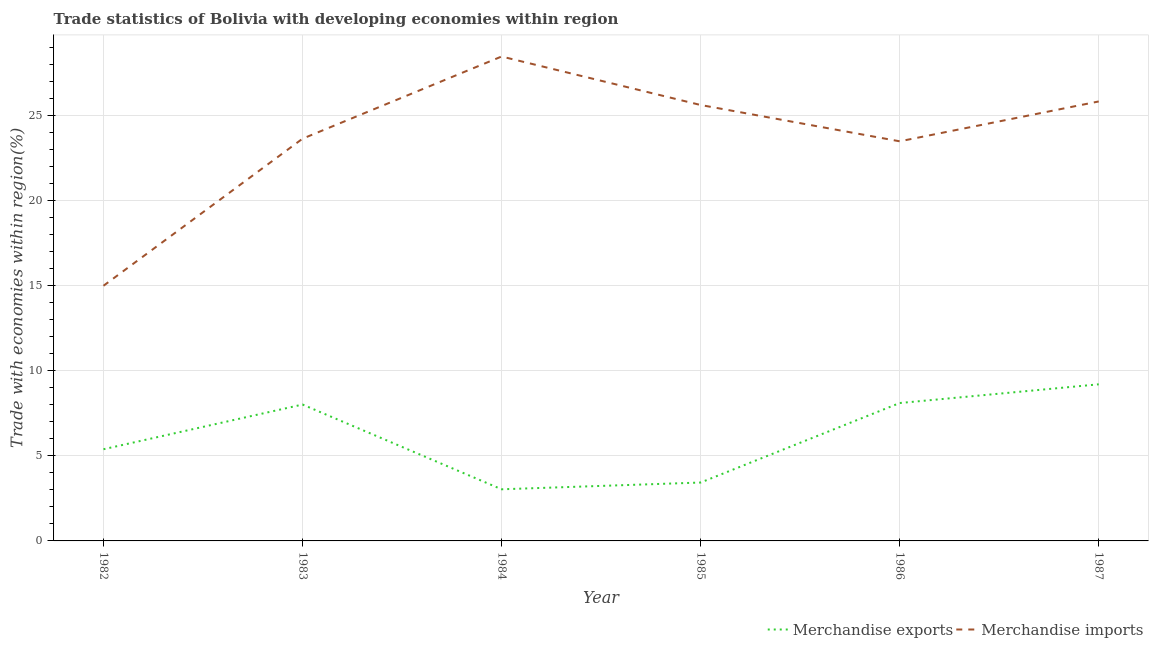How many different coloured lines are there?
Your response must be concise. 2. Does the line corresponding to merchandise imports intersect with the line corresponding to merchandise exports?
Offer a terse response. No. Is the number of lines equal to the number of legend labels?
Give a very brief answer. Yes. What is the merchandise exports in 1986?
Your answer should be compact. 8.1. Across all years, what is the maximum merchandise imports?
Offer a terse response. 28.47. Across all years, what is the minimum merchandise imports?
Your answer should be very brief. 15. In which year was the merchandise exports maximum?
Your answer should be very brief. 1987. In which year was the merchandise imports minimum?
Your answer should be very brief. 1982. What is the total merchandise imports in the graph?
Offer a very short reply. 142.05. What is the difference between the merchandise imports in 1983 and that in 1987?
Offer a very short reply. -2.19. What is the difference between the merchandise imports in 1985 and the merchandise exports in 1983?
Your response must be concise. 17.6. What is the average merchandise exports per year?
Your answer should be very brief. 6.2. In the year 1984, what is the difference between the merchandise imports and merchandise exports?
Your answer should be very brief. 25.44. In how many years, is the merchandise imports greater than 27 %?
Your answer should be very brief. 1. What is the ratio of the merchandise imports in 1982 to that in 1986?
Keep it short and to the point. 0.64. What is the difference between the highest and the second highest merchandise exports?
Your response must be concise. 1.1. What is the difference between the highest and the lowest merchandise exports?
Provide a short and direct response. 6.17. In how many years, is the merchandise imports greater than the average merchandise imports taken over all years?
Your answer should be very brief. 3. Is the sum of the merchandise exports in 1985 and 1987 greater than the maximum merchandise imports across all years?
Your response must be concise. No. Does the merchandise imports monotonically increase over the years?
Offer a very short reply. No. What is the difference between two consecutive major ticks on the Y-axis?
Your answer should be compact. 5. Does the graph contain any zero values?
Ensure brevity in your answer.  No. Where does the legend appear in the graph?
Ensure brevity in your answer.  Bottom right. How many legend labels are there?
Give a very brief answer. 2. How are the legend labels stacked?
Make the answer very short. Horizontal. What is the title of the graph?
Your answer should be compact. Trade statistics of Bolivia with developing economies within region. What is the label or title of the X-axis?
Keep it short and to the point. Year. What is the label or title of the Y-axis?
Give a very brief answer. Trade with economies within region(%). What is the Trade with economies within region(%) in Merchandise exports in 1982?
Make the answer very short. 5.39. What is the Trade with economies within region(%) in Merchandise imports in 1982?
Provide a succinct answer. 15. What is the Trade with economies within region(%) of Merchandise exports in 1983?
Your answer should be very brief. 8.02. What is the Trade with economies within region(%) in Merchandise imports in 1983?
Keep it short and to the point. 23.64. What is the Trade with economies within region(%) of Merchandise exports in 1984?
Provide a succinct answer. 3.04. What is the Trade with economies within region(%) of Merchandise imports in 1984?
Offer a terse response. 28.47. What is the Trade with economies within region(%) in Merchandise exports in 1985?
Make the answer very short. 3.43. What is the Trade with economies within region(%) in Merchandise imports in 1985?
Give a very brief answer. 25.62. What is the Trade with economies within region(%) of Merchandise exports in 1986?
Offer a very short reply. 8.1. What is the Trade with economies within region(%) of Merchandise imports in 1986?
Your response must be concise. 23.49. What is the Trade with economies within region(%) in Merchandise exports in 1987?
Your answer should be very brief. 9.2. What is the Trade with economies within region(%) of Merchandise imports in 1987?
Give a very brief answer. 25.83. Across all years, what is the maximum Trade with economies within region(%) in Merchandise exports?
Offer a very short reply. 9.2. Across all years, what is the maximum Trade with economies within region(%) in Merchandise imports?
Provide a succinct answer. 28.47. Across all years, what is the minimum Trade with economies within region(%) of Merchandise exports?
Offer a very short reply. 3.04. Across all years, what is the minimum Trade with economies within region(%) of Merchandise imports?
Provide a short and direct response. 15. What is the total Trade with economies within region(%) in Merchandise exports in the graph?
Your answer should be compact. 37.18. What is the total Trade with economies within region(%) of Merchandise imports in the graph?
Keep it short and to the point. 142.05. What is the difference between the Trade with economies within region(%) of Merchandise exports in 1982 and that in 1983?
Your response must be concise. -2.63. What is the difference between the Trade with economies within region(%) in Merchandise imports in 1982 and that in 1983?
Provide a succinct answer. -8.64. What is the difference between the Trade with economies within region(%) in Merchandise exports in 1982 and that in 1984?
Keep it short and to the point. 2.35. What is the difference between the Trade with economies within region(%) of Merchandise imports in 1982 and that in 1984?
Your answer should be compact. -13.47. What is the difference between the Trade with economies within region(%) of Merchandise exports in 1982 and that in 1985?
Offer a very short reply. 1.96. What is the difference between the Trade with economies within region(%) of Merchandise imports in 1982 and that in 1985?
Your answer should be very brief. -10.62. What is the difference between the Trade with economies within region(%) in Merchandise exports in 1982 and that in 1986?
Offer a very short reply. -2.72. What is the difference between the Trade with economies within region(%) in Merchandise imports in 1982 and that in 1986?
Give a very brief answer. -8.49. What is the difference between the Trade with economies within region(%) in Merchandise exports in 1982 and that in 1987?
Give a very brief answer. -3.82. What is the difference between the Trade with economies within region(%) in Merchandise imports in 1982 and that in 1987?
Ensure brevity in your answer.  -10.83. What is the difference between the Trade with economies within region(%) in Merchandise exports in 1983 and that in 1984?
Provide a succinct answer. 4.98. What is the difference between the Trade with economies within region(%) of Merchandise imports in 1983 and that in 1984?
Your response must be concise. -4.83. What is the difference between the Trade with economies within region(%) in Merchandise exports in 1983 and that in 1985?
Offer a very short reply. 4.58. What is the difference between the Trade with economies within region(%) of Merchandise imports in 1983 and that in 1985?
Make the answer very short. -1.98. What is the difference between the Trade with economies within region(%) in Merchandise exports in 1983 and that in 1986?
Offer a terse response. -0.09. What is the difference between the Trade with economies within region(%) of Merchandise imports in 1983 and that in 1986?
Your answer should be compact. 0.15. What is the difference between the Trade with economies within region(%) in Merchandise exports in 1983 and that in 1987?
Provide a short and direct response. -1.19. What is the difference between the Trade with economies within region(%) in Merchandise imports in 1983 and that in 1987?
Your response must be concise. -2.19. What is the difference between the Trade with economies within region(%) in Merchandise exports in 1984 and that in 1985?
Provide a succinct answer. -0.4. What is the difference between the Trade with economies within region(%) in Merchandise imports in 1984 and that in 1985?
Ensure brevity in your answer.  2.85. What is the difference between the Trade with economies within region(%) in Merchandise exports in 1984 and that in 1986?
Provide a succinct answer. -5.07. What is the difference between the Trade with economies within region(%) in Merchandise imports in 1984 and that in 1986?
Your answer should be very brief. 4.98. What is the difference between the Trade with economies within region(%) of Merchandise exports in 1984 and that in 1987?
Your answer should be compact. -6.17. What is the difference between the Trade with economies within region(%) in Merchandise imports in 1984 and that in 1987?
Offer a terse response. 2.64. What is the difference between the Trade with economies within region(%) of Merchandise exports in 1985 and that in 1986?
Your response must be concise. -4.67. What is the difference between the Trade with economies within region(%) of Merchandise imports in 1985 and that in 1986?
Keep it short and to the point. 2.13. What is the difference between the Trade with economies within region(%) in Merchandise exports in 1985 and that in 1987?
Provide a succinct answer. -5.77. What is the difference between the Trade with economies within region(%) of Merchandise imports in 1985 and that in 1987?
Provide a succinct answer. -0.21. What is the difference between the Trade with economies within region(%) of Merchandise exports in 1986 and that in 1987?
Offer a terse response. -1.1. What is the difference between the Trade with economies within region(%) of Merchandise imports in 1986 and that in 1987?
Provide a short and direct response. -2.34. What is the difference between the Trade with economies within region(%) in Merchandise exports in 1982 and the Trade with economies within region(%) in Merchandise imports in 1983?
Offer a terse response. -18.25. What is the difference between the Trade with economies within region(%) in Merchandise exports in 1982 and the Trade with economies within region(%) in Merchandise imports in 1984?
Ensure brevity in your answer.  -23.08. What is the difference between the Trade with economies within region(%) in Merchandise exports in 1982 and the Trade with economies within region(%) in Merchandise imports in 1985?
Give a very brief answer. -20.23. What is the difference between the Trade with economies within region(%) of Merchandise exports in 1982 and the Trade with economies within region(%) of Merchandise imports in 1986?
Keep it short and to the point. -18.1. What is the difference between the Trade with economies within region(%) in Merchandise exports in 1982 and the Trade with economies within region(%) in Merchandise imports in 1987?
Provide a succinct answer. -20.44. What is the difference between the Trade with economies within region(%) of Merchandise exports in 1983 and the Trade with economies within region(%) of Merchandise imports in 1984?
Make the answer very short. -20.46. What is the difference between the Trade with economies within region(%) of Merchandise exports in 1983 and the Trade with economies within region(%) of Merchandise imports in 1985?
Offer a terse response. -17.6. What is the difference between the Trade with economies within region(%) of Merchandise exports in 1983 and the Trade with economies within region(%) of Merchandise imports in 1986?
Your answer should be compact. -15.47. What is the difference between the Trade with economies within region(%) in Merchandise exports in 1983 and the Trade with economies within region(%) in Merchandise imports in 1987?
Provide a succinct answer. -17.81. What is the difference between the Trade with economies within region(%) in Merchandise exports in 1984 and the Trade with economies within region(%) in Merchandise imports in 1985?
Your answer should be compact. -22.59. What is the difference between the Trade with economies within region(%) of Merchandise exports in 1984 and the Trade with economies within region(%) of Merchandise imports in 1986?
Your response must be concise. -20.45. What is the difference between the Trade with economies within region(%) of Merchandise exports in 1984 and the Trade with economies within region(%) of Merchandise imports in 1987?
Keep it short and to the point. -22.8. What is the difference between the Trade with economies within region(%) of Merchandise exports in 1985 and the Trade with economies within region(%) of Merchandise imports in 1986?
Ensure brevity in your answer.  -20.06. What is the difference between the Trade with economies within region(%) in Merchandise exports in 1985 and the Trade with economies within region(%) in Merchandise imports in 1987?
Your response must be concise. -22.4. What is the difference between the Trade with economies within region(%) of Merchandise exports in 1986 and the Trade with economies within region(%) of Merchandise imports in 1987?
Your answer should be very brief. -17.73. What is the average Trade with economies within region(%) of Merchandise exports per year?
Provide a short and direct response. 6.2. What is the average Trade with economies within region(%) in Merchandise imports per year?
Your response must be concise. 23.67. In the year 1982, what is the difference between the Trade with economies within region(%) in Merchandise exports and Trade with economies within region(%) in Merchandise imports?
Offer a very short reply. -9.61. In the year 1983, what is the difference between the Trade with economies within region(%) in Merchandise exports and Trade with economies within region(%) in Merchandise imports?
Provide a succinct answer. -15.62. In the year 1984, what is the difference between the Trade with economies within region(%) of Merchandise exports and Trade with economies within region(%) of Merchandise imports?
Ensure brevity in your answer.  -25.44. In the year 1985, what is the difference between the Trade with economies within region(%) of Merchandise exports and Trade with economies within region(%) of Merchandise imports?
Provide a short and direct response. -22.19. In the year 1986, what is the difference between the Trade with economies within region(%) in Merchandise exports and Trade with economies within region(%) in Merchandise imports?
Your answer should be very brief. -15.38. In the year 1987, what is the difference between the Trade with economies within region(%) in Merchandise exports and Trade with economies within region(%) in Merchandise imports?
Ensure brevity in your answer.  -16.63. What is the ratio of the Trade with economies within region(%) in Merchandise exports in 1982 to that in 1983?
Provide a succinct answer. 0.67. What is the ratio of the Trade with economies within region(%) of Merchandise imports in 1982 to that in 1983?
Make the answer very short. 0.63. What is the ratio of the Trade with economies within region(%) of Merchandise exports in 1982 to that in 1984?
Keep it short and to the point. 1.78. What is the ratio of the Trade with economies within region(%) in Merchandise imports in 1982 to that in 1984?
Keep it short and to the point. 0.53. What is the ratio of the Trade with economies within region(%) in Merchandise exports in 1982 to that in 1985?
Your response must be concise. 1.57. What is the ratio of the Trade with economies within region(%) of Merchandise imports in 1982 to that in 1985?
Make the answer very short. 0.59. What is the ratio of the Trade with economies within region(%) in Merchandise exports in 1982 to that in 1986?
Provide a short and direct response. 0.66. What is the ratio of the Trade with economies within region(%) in Merchandise imports in 1982 to that in 1986?
Provide a short and direct response. 0.64. What is the ratio of the Trade with economies within region(%) of Merchandise exports in 1982 to that in 1987?
Give a very brief answer. 0.59. What is the ratio of the Trade with economies within region(%) in Merchandise imports in 1982 to that in 1987?
Offer a very short reply. 0.58. What is the ratio of the Trade with economies within region(%) in Merchandise exports in 1983 to that in 1984?
Ensure brevity in your answer.  2.64. What is the ratio of the Trade with economies within region(%) in Merchandise imports in 1983 to that in 1984?
Your answer should be very brief. 0.83. What is the ratio of the Trade with economies within region(%) of Merchandise exports in 1983 to that in 1985?
Your answer should be compact. 2.34. What is the ratio of the Trade with economies within region(%) in Merchandise imports in 1983 to that in 1985?
Ensure brevity in your answer.  0.92. What is the ratio of the Trade with economies within region(%) in Merchandise exports in 1983 to that in 1986?
Make the answer very short. 0.99. What is the ratio of the Trade with economies within region(%) of Merchandise exports in 1983 to that in 1987?
Offer a terse response. 0.87. What is the ratio of the Trade with economies within region(%) of Merchandise imports in 1983 to that in 1987?
Provide a succinct answer. 0.92. What is the ratio of the Trade with economies within region(%) in Merchandise exports in 1984 to that in 1985?
Your answer should be compact. 0.88. What is the ratio of the Trade with economies within region(%) in Merchandise imports in 1984 to that in 1985?
Provide a succinct answer. 1.11. What is the ratio of the Trade with economies within region(%) in Merchandise exports in 1984 to that in 1986?
Your answer should be compact. 0.37. What is the ratio of the Trade with economies within region(%) in Merchandise imports in 1984 to that in 1986?
Give a very brief answer. 1.21. What is the ratio of the Trade with economies within region(%) in Merchandise exports in 1984 to that in 1987?
Ensure brevity in your answer.  0.33. What is the ratio of the Trade with economies within region(%) in Merchandise imports in 1984 to that in 1987?
Offer a terse response. 1.1. What is the ratio of the Trade with economies within region(%) in Merchandise exports in 1985 to that in 1986?
Offer a very short reply. 0.42. What is the ratio of the Trade with economies within region(%) in Merchandise imports in 1985 to that in 1986?
Keep it short and to the point. 1.09. What is the ratio of the Trade with economies within region(%) in Merchandise exports in 1985 to that in 1987?
Your answer should be compact. 0.37. What is the ratio of the Trade with economies within region(%) of Merchandise exports in 1986 to that in 1987?
Give a very brief answer. 0.88. What is the ratio of the Trade with economies within region(%) in Merchandise imports in 1986 to that in 1987?
Your answer should be very brief. 0.91. What is the difference between the highest and the second highest Trade with economies within region(%) of Merchandise exports?
Your answer should be very brief. 1.1. What is the difference between the highest and the second highest Trade with economies within region(%) in Merchandise imports?
Keep it short and to the point. 2.64. What is the difference between the highest and the lowest Trade with economies within region(%) of Merchandise exports?
Your response must be concise. 6.17. What is the difference between the highest and the lowest Trade with economies within region(%) in Merchandise imports?
Your answer should be compact. 13.47. 